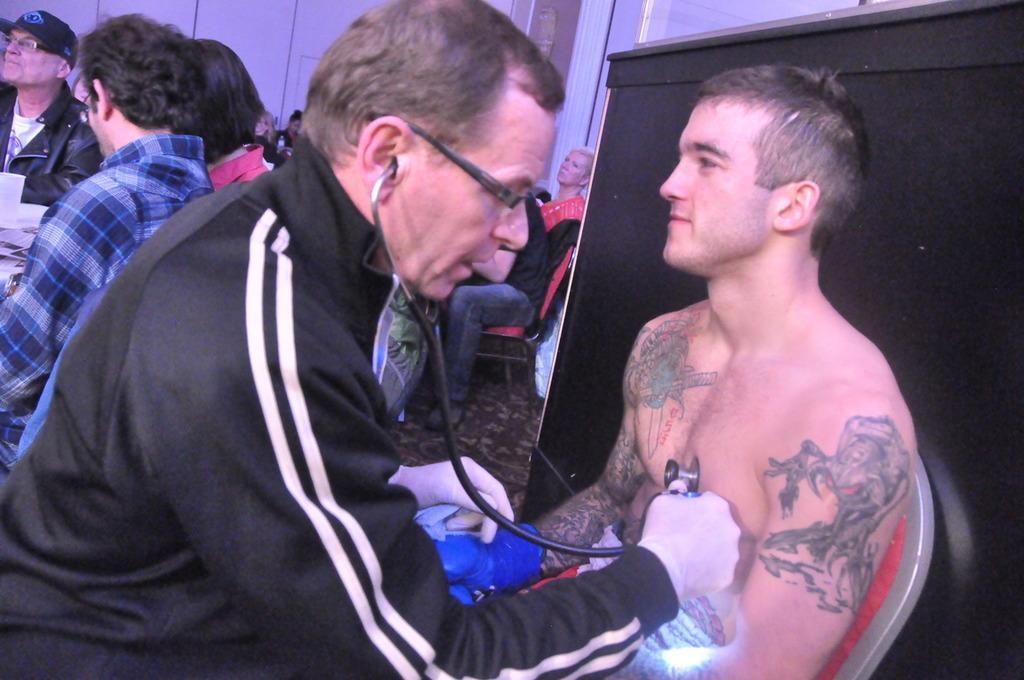Please provide a concise description of this image. In this image, there are a few people. We can see the ground. We can see some posters on the left. We can also see a black colored object on the right. We can see the wall. 